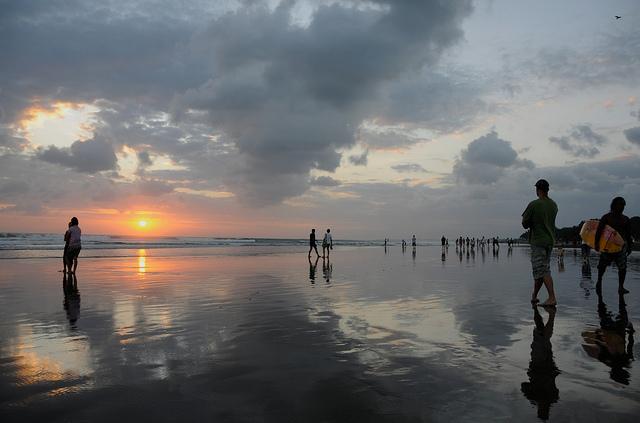Does this appear to be in a large city?
Answer briefly. No. Is anyone in the photo?
Quick response, please. Yes. What are the couple looking at?
Be succinct. Sunset. Are the people sitting on a bench?
Concise answer only. No. Is it raining in this scene?
Be succinct. No. How many individuals are visible in this picture?
Keep it brief. 20. What holiday is near?
Give a very brief answer. Christmas. What is this person doing?
Quick response, please. Walking. What type of vessels are in the water?
Give a very brief answer. Surfboards. How many cars are in the scene?
Keep it brief. 0. Is there a bike in the photo?
Keep it brief. No. Is there supposed to be water here?
Answer briefly. Yes. Is this sunset/sunrise?
Be succinct. Sunset. Are the people on the left a couple?
Quick response, please. Yes. Are there any lights?
Answer briefly. No. What types of clouds are in the sky?
Short answer required. Cumulus. What is this a picture of?
Be succinct. Beach. Why is the ground reflective?
Write a very short answer. Wet. Where is the water?
Write a very short answer. In ocean. What's in the background?
Be succinct. Sunset. How deep is the water?
Be succinct. Shallow. Is it warm in the photo?
Quick response, please. Yes. Can you see the far shore?
Give a very brief answer. No. Is this a major city?
Quick response, please. No. Are there any people around?
Concise answer only. Yes. Are the humans in the picture having a romantic moment?
Answer briefly. Yes. What is in the water?
Answer briefly. People. How many people in this photo?
Write a very short answer. 20. What can the people put their garbage in?
Keep it brief. Trash can. What color is the surfboard?
Short answer required. Orange. 